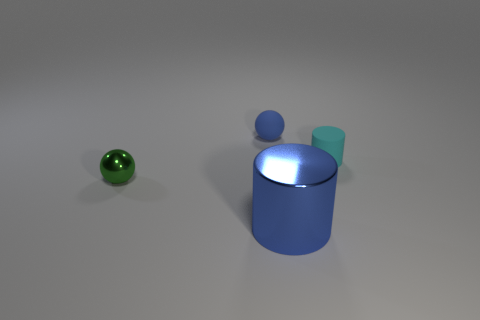Are there any other things that have the same size as the metallic cylinder?
Make the answer very short. No. Are there any large blue shiny objects left of the rubber thing that is right of the large blue object?
Your answer should be very brief. Yes. Are there fewer large yellow rubber balls than small blue balls?
Provide a succinct answer. Yes. How many blue metallic objects are the same shape as the blue rubber object?
Your answer should be very brief. 0. What number of green objects are either balls or small cylinders?
Provide a short and direct response. 1. How big is the ball that is on the left side of the blue thing on the left side of the big blue cylinder?
Give a very brief answer. Small. There is another object that is the same shape as the green thing; what is it made of?
Offer a terse response. Rubber. What number of spheres have the same size as the matte cylinder?
Your response must be concise. 2. Do the blue rubber ball and the green metallic object have the same size?
Give a very brief answer. Yes. There is a object that is in front of the cyan matte object and behind the metal cylinder; what size is it?
Offer a very short reply. Small. 